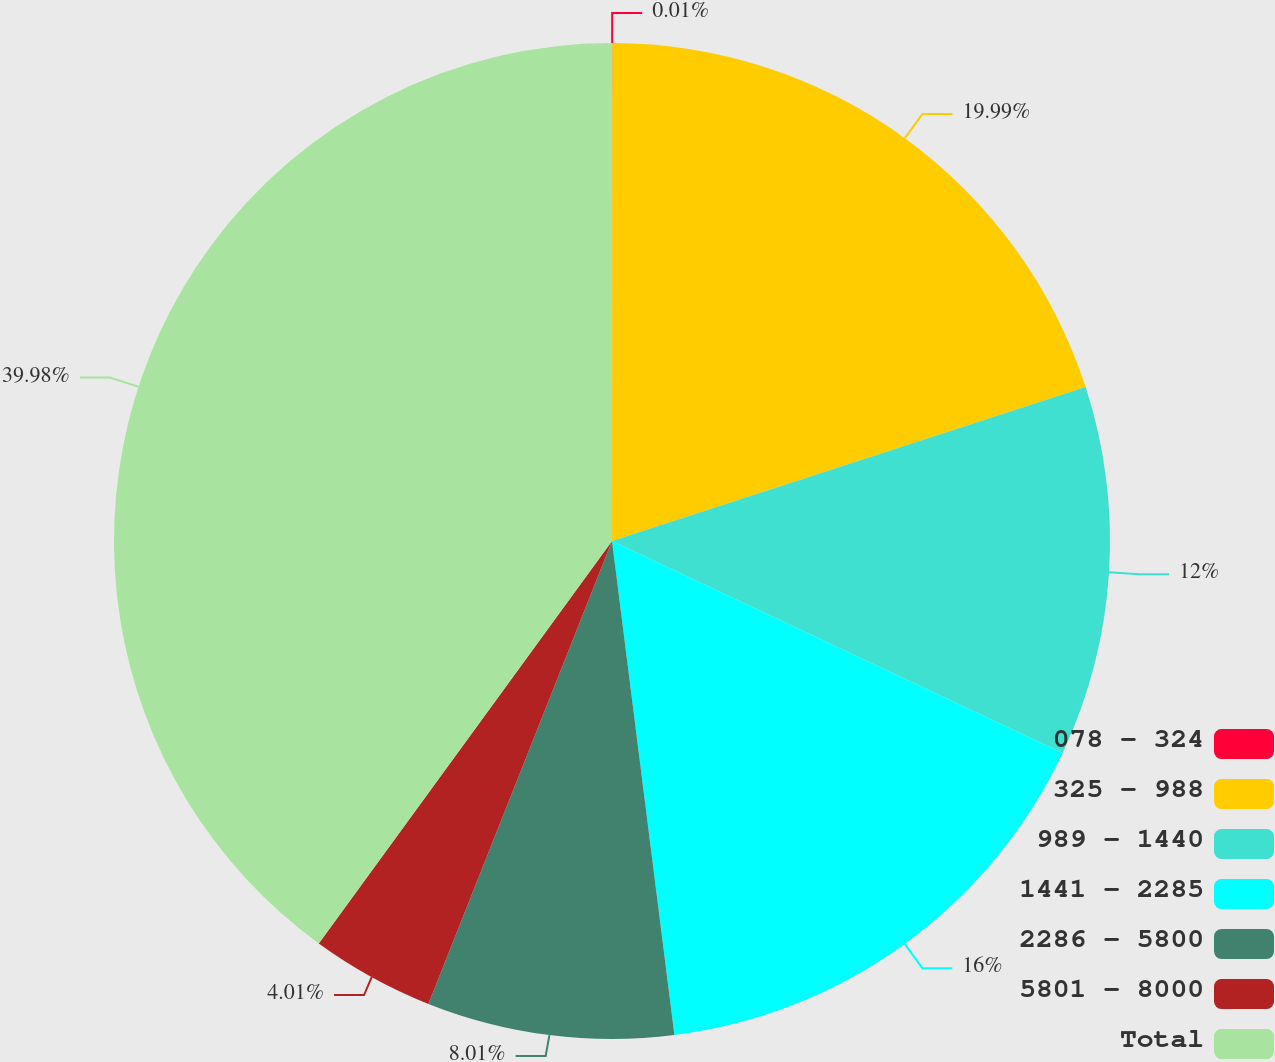Convert chart to OTSL. <chart><loc_0><loc_0><loc_500><loc_500><pie_chart><fcel>078 - 324<fcel>325 - 988<fcel>989 - 1440<fcel>1441 - 2285<fcel>2286 - 5800<fcel>5801 - 8000<fcel>Total<nl><fcel>0.01%<fcel>19.99%<fcel>12.0%<fcel>16.0%<fcel>8.01%<fcel>4.01%<fcel>39.98%<nl></chart> 